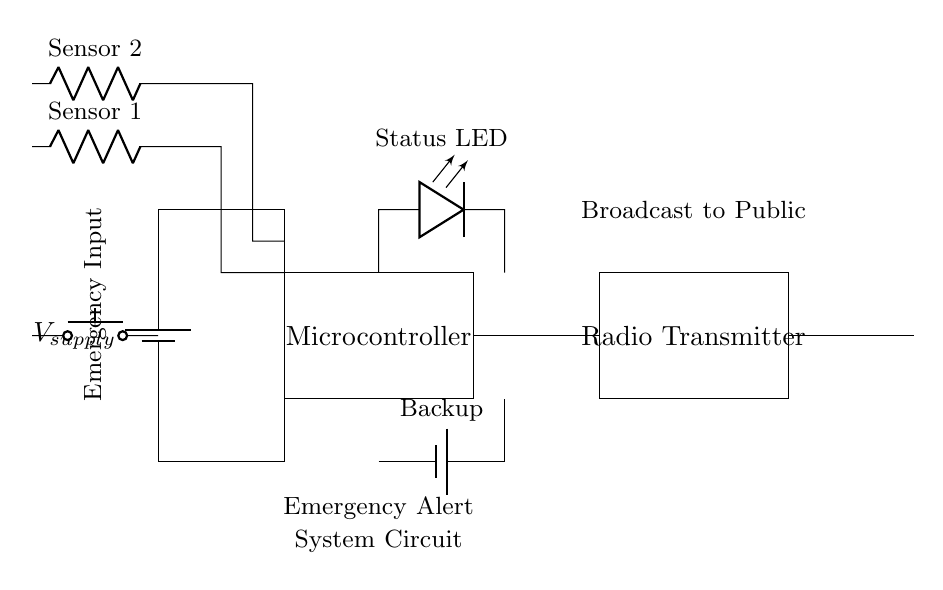What is the main power supply in the circuit? The main power supply is represented by the battery symbol labeled V_supply, which provides the necessary voltage for the circuit to operate.
Answer: V_supply What are the two types of inputs for the emergency alert system? The circuit has two types of inputs: an emergency input button and two sensor inputs. These are indicated by the push button and two resistors connected to sensors.
Answer: Emergency input button and sensor inputs What is the purpose of the microcontroller in this circuit? The microcontroller processes the signals from the emergency input and sensor inputs and controls the operation of the radio transmitter based on those inputs.
Answer: Control How does the backup battery function in this circuit? The backup battery ensures that the circuit can still operate during a power failure by providing an alternative power source, thereby maintaining functionality for emergency alerts.
Answer: Alternative power source How many sensors are present in the circuit, and what are they labeled? There are two sensors in the circuit, labeled as Sensor 1 and Sensor 2. They are represented by the resistor symbols connected to the inputs.
Answer: Two sensors: Sensor 1 and Sensor 2 What does the LED indicate in this emergency alert system? The LED serves as a status indicator, showing whether the system is active or functioning properly, which is crucial for ensuring that the system alerts the public effectively.
Answer: Status indicator What is transmitted from the radio transmitter? The radio transmitter broadcasts critical information to the public, as indicated in the labels within the circuit diagram.
Answer: Critical information 